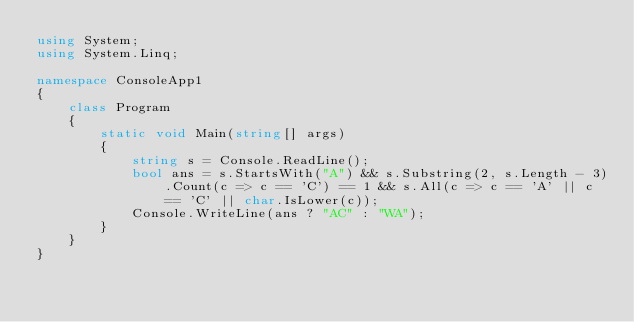Convert code to text. <code><loc_0><loc_0><loc_500><loc_500><_C#_>using System;
using System.Linq;

namespace ConsoleApp1
{
    class Program
    {
        static void Main(string[] args)
        {
            string s = Console.ReadLine();
            bool ans = s.StartsWith("A") && s.Substring(2, s.Length - 3).Count(c => c == 'C') == 1 && s.All(c => c == 'A' || c == 'C' || char.IsLower(c));
            Console.WriteLine(ans ? "AC" : "WA");
        }
    }
}</code> 